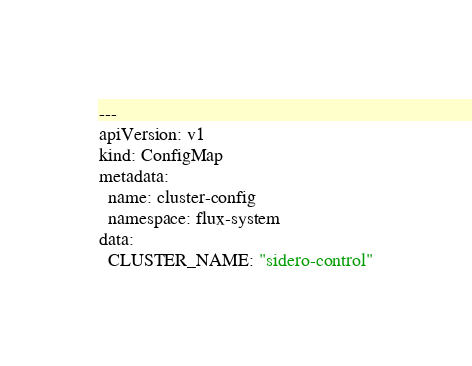Convert code to text. <code><loc_0><loc_0><loc_500><loc_500><_YAML_>---
apiVersion: v1
kind: ConfigMap
metadata:
  name: cluster-config
  namespace: flux-system
data:
  CLUSTER_NAME: "sidero-control"
</code> 